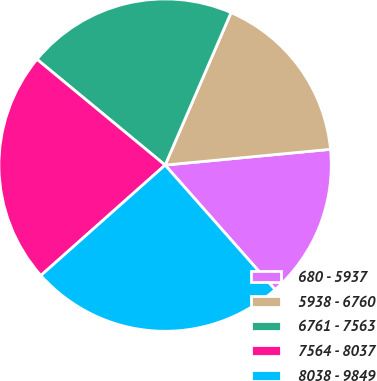Convert chart. <chart><loc_0><loc_0><loc_500><loc_500><pie_chart><fcel>680 - 5937<fcel>5938 - 6760<fcel>6761 - 7563<fcel>7564 - 8037<fcel>8038 - 9849<nl><fcel>15.0%<fcel>16.99%<fcel>20.51%<fcel>22.55%<fcel>24.95%<nl></chart> 